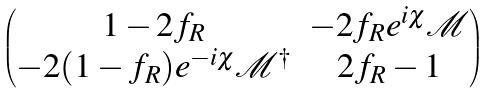Convert formula to latex. <formula><loc_0><loc_0><loc_500><loc_500>\begin{pmatrix} 1 - 2 f _ { R } & - 2 f _ { R } e ^ { i \chi } \mathcal { M } \\ - 2 ( 1 - f _ { R } ) e ^ { - i \chi } \mathcal { M } ^ { \dagger } & 2 f _ { R } - 1 \end{pmatrix}</formula> 